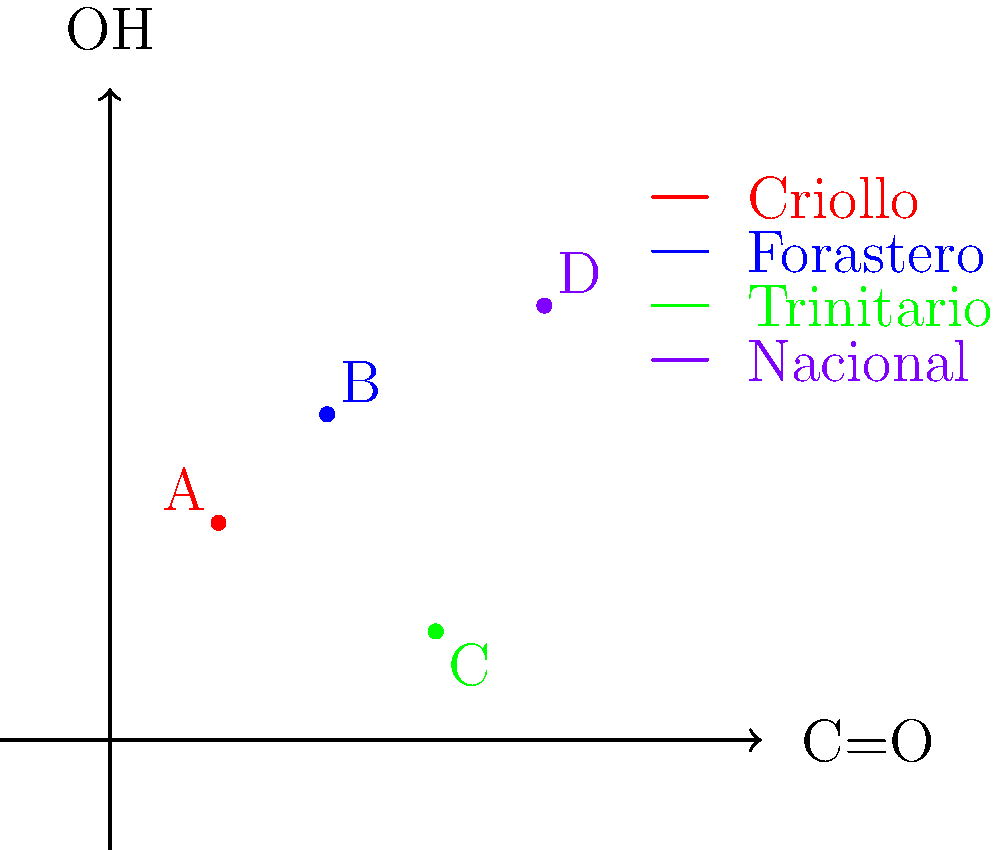As a chocolate manufacturer committed to fair trade, you're analyzing the chemical composition of different cocoa varieties. The graph shows the relative concentrations of carbonyl (C=O) and hydroxyl (OH) groups in four cocoa varieties. Which variety has the highest total concentration of these functional groups, and how might this impact its flavor profile and potential use in fair trade chocolate production? To answer this question, we need to follow these steps:

1. Identify the cocoa varieties on the graph:
   A (red): Criollo
   B (blue): Forastero
   C (green): Trinitario
   D (purple): Nacional

2. Calculate the total concentration for each variety:
   Total concentration = C=O concentration + OH concentration

   Criollo (A): 1 + 2 = 3
   Forastero (B): 2 + 3 = 5
   Trinitario (C): 3 + 1 = 4
   Nacional (D): 4 + 4 = 8

3. Determine the variety with the highest total concentration:
   Nacional (D) has the highest total concentration of 8.

4. Analyze the impact on flavor profile:
   Higher concentrations of carbonyl groups (C=O) typically contribute to nutty, roasted flavors, while hydroxyl groups (OH) often contribute to sweetness and fruitiness.

5. Consider the impact on fair trade chocolate production:
   - Nacional cocoa's complex flavor profile could command premium prices, benefiting fair trade farmers.
   - The unique chemical composition may require specific processing techniques, potentially creating specialized job opportunities in fair trade cooperatives.
   - The distinctive flavor could be marketed as a specialty product, increasing demand for fair trade cocoa.
Answer: Nacional variety; highest flavor complexity, potential for premium pricing and specialized processing in fair trade production. 